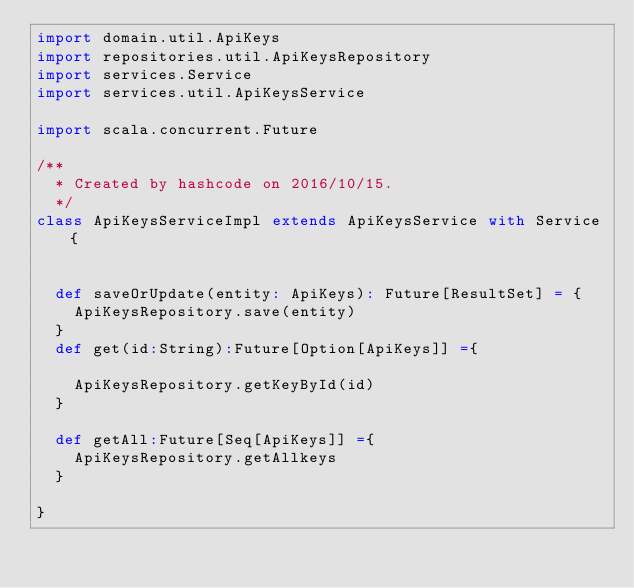<code> <loc_0><loc_0><loc_500><loc_500><_Scala_>import domain.util.ApiKeys
import repositories.util.ApiKeysRepository
import services.Service
import services.util.ApiKeysService

import scala.concurrent.Future

/**
  * Created by hashcode on 2016/10/15.
  */
class ApiKeysServiceImpl extends ApiKeysService with Service{


  def saveOrUpdate(entity: ApiKeys): Future[ResultSet] = {
    ApiKeysRepository.save(entity)
  }
  def get(id:String):Future[Option[ApiKeys]] ={

    ApiKeysRepository.getKeyById(id)
  }

  def getAll:Future[Seq[ApiKeys]] ={
    ApiKeysRepository.getAllkeys
  }

}
</code> 